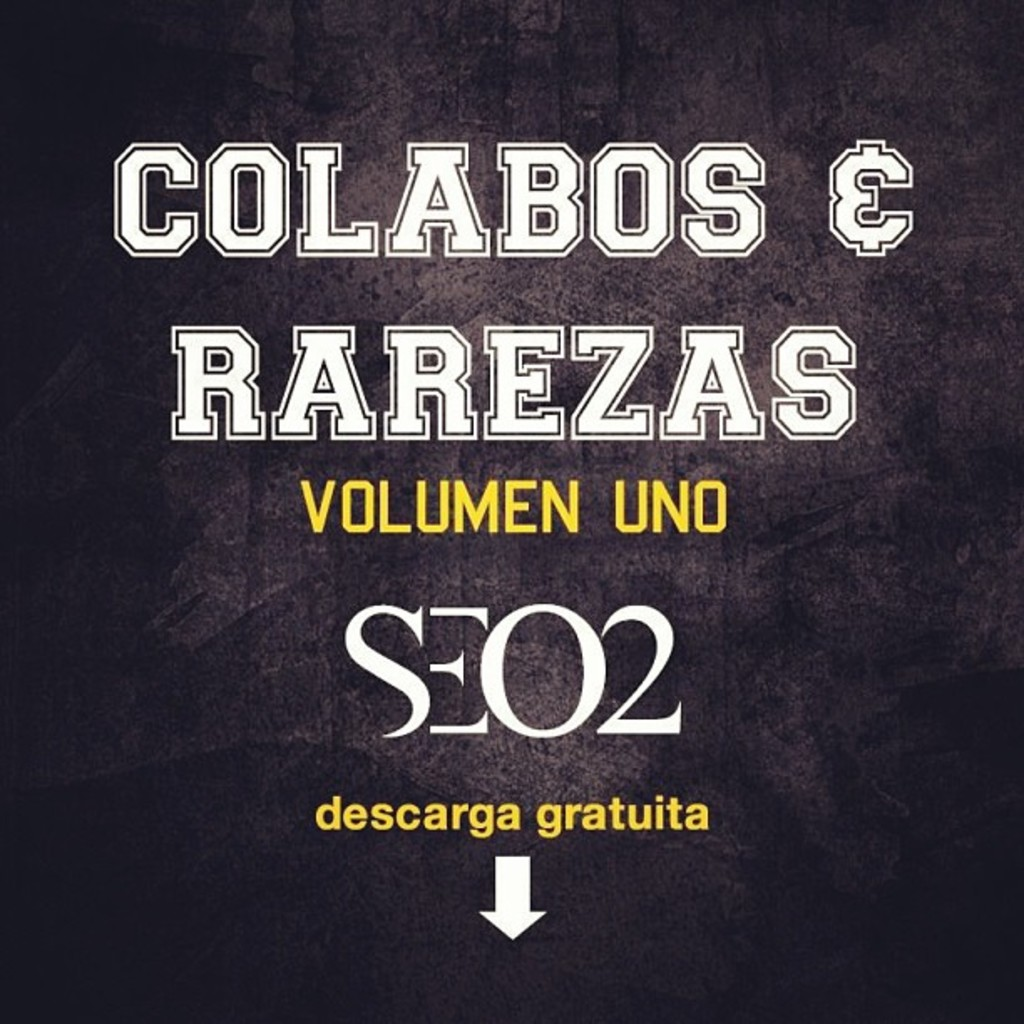What do you think is going on in this snapshot? This image appears to be the cover art for an album called "Colabos & Rarezas Volumen Uno" by SEO2. It features a gritty black textured background which gives it a raw, urban feel, contrasting with the bold white and yellow typography that stands out. At the bottom, an arrow points downwards accompanying the words 'descarga gratuita,' translating to 'free download' in English, suggesting that the album can be accessed without cost. The design is simple yet striking, encapsulating a sense of simplicity with a direct message. 